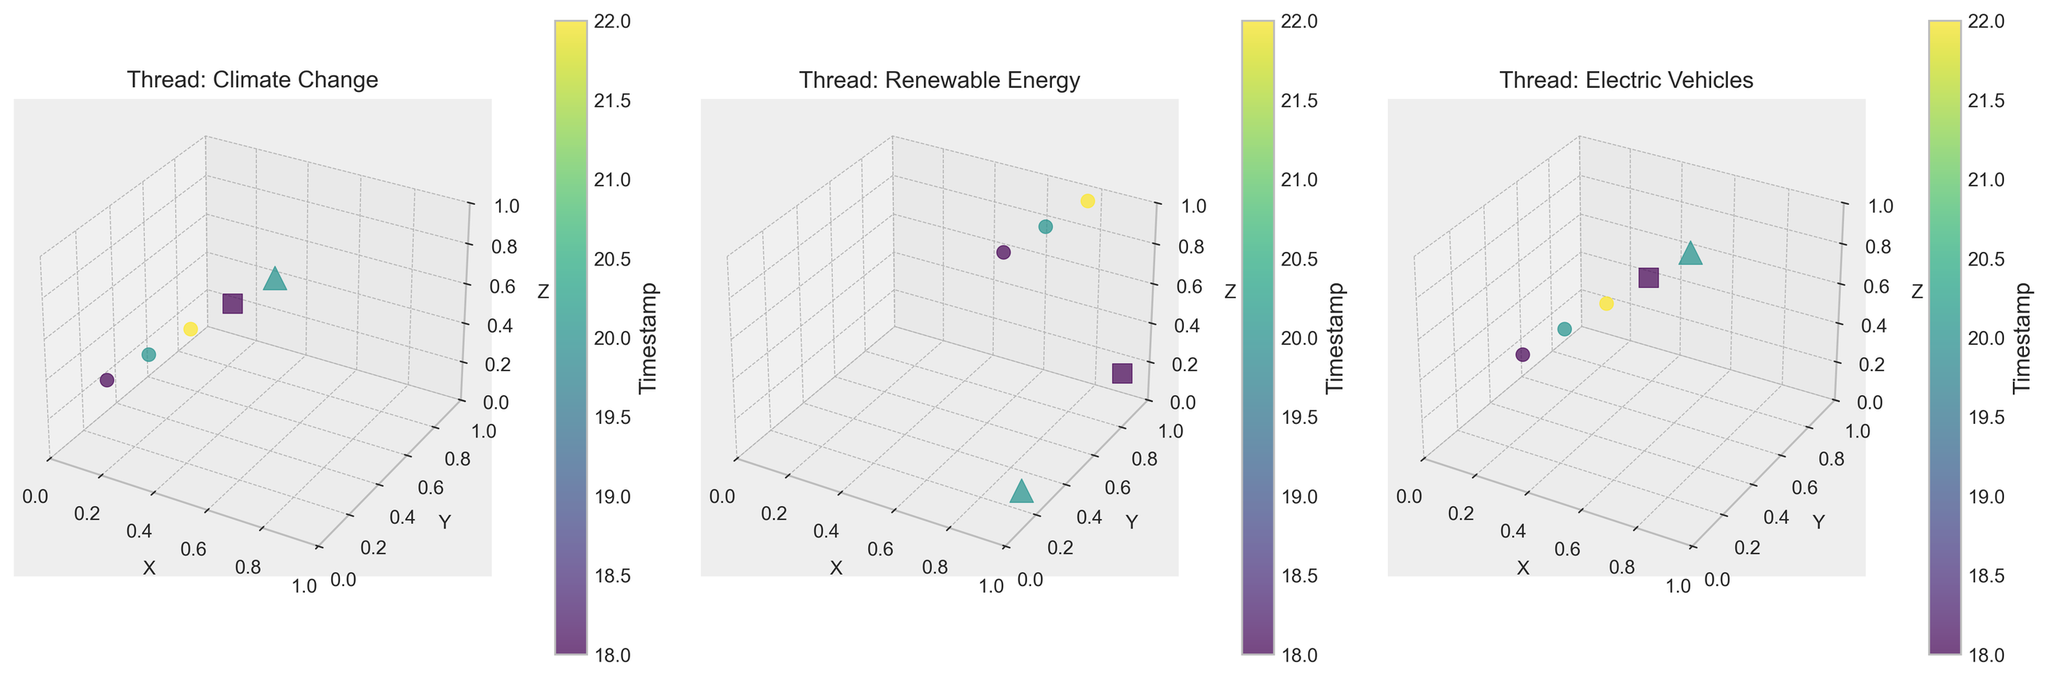What is the topic of the first subplot? The title of the first subplot displayed at the top is derived from the 'topic' column data. The topic of the first subplot is visible as "Climate Change".
Answer: Climate Change How many derailment points are in the thread about Electric Vehicles? By checking the scatter plot markers in the third subplot, specifically looking for data points marked with squares (denoting derailment), there is one such point in the Electric Vehicles thread.
Answer: 1 What moderator action was taken at the derailment point in the Renewable Energy thread? In the second subplot, the derailment point can be identified by the square marker, with an adjacent triangle marker indicating the subsequent moderator action which is listed as 'remove_comment' in the data.
Answer: remove_comment Are there any derailment points in the first thread without subsequent moderator actions? In the first subplot, we observe the 3D space for square markers (derailment points). Each derailment point should be followed or tagged by a triangle marker for moderator action. There is a derailment indicator, "FossilFuelLobby," followed by "Moderator," indicating that all derailment points have subsequent moderator actions.
Answer: No In which thread do users show the highest participation in the on-topic discussions? By comparing the number of circular markers (on-topic points) across all three subplots, the Renewable Energy thread in the second subplot has the highest number of circular markers (3).
Answer: Renewable Energy How many data points are there in total for the Climate Change thread? Summing the number of all types of markers (circles, squares, and triangles) in the first subplot gives the total number of data points in the Climate Change thread, which is 5.
Answer: 5 Which marker type is used to indicate derailment points? By referring to the legend and markers in the plot, we notice that square markers are used to indicate derailment points.
Answer: Square What happens at timestamp 10 in the Electric Vehicles thread? Observing the marker at the timestamp of 10 in the third subplot for the Electric Vehicles thread, we see a circular marker indicating an on-topic discussion point.
Answer: On-topic discussion How do the timestamps progress in the plot for the Renewable Energy thread? The progression of time in the second subplot is shown through the color gradient of the markers, moving from lighter to darker shades as time increases.
Answer: Lighter to darker colors 